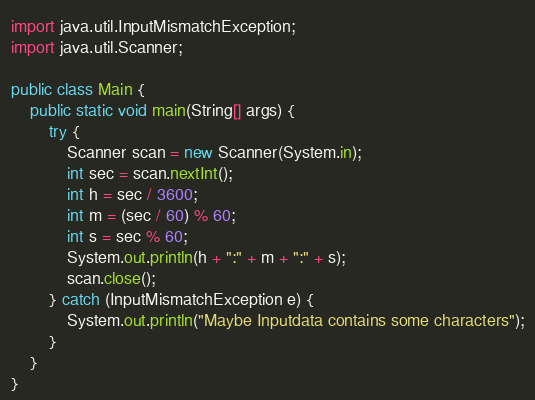Convert code to text. <code><loc_0><loc_0><loc_500><loc_500><_Java_>import java.util.InputMismatchException;
import java.util.Scanner;

public class Main {
	public static void main(String[] args) {
		try {
			Scanner scan = new Scanner(System.in);
			int sec = scan.nextInt();
			int h = sec / 3600;
			int m = (sec / 60) % 60;
			int s = sec % 60;
			System.out.println(h + ":" + m + ":" + s);
			scan.close();
		} catch (InputMismatchException e) {
			System.out.println("Maybe Inputdata contains some characters");
		}
	}
}</code> 